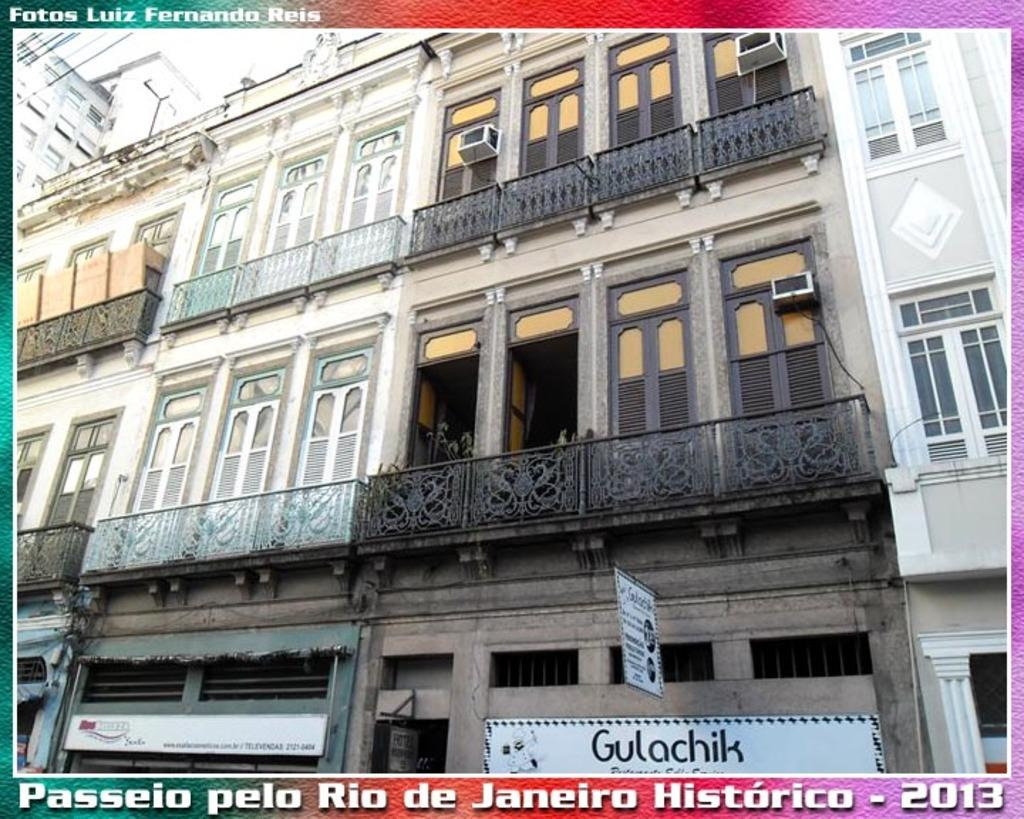What can be seen in the foreground of the image? In the foreground of the image, there are buildings, railings, and boards. Can you describe the buildings in the foreground? The buildings in the foreground are likely structures or establishments. What are the railings used for in the image? The railings in the foreground may be used for safety or to guide people. What are the boards in the foreground used for? The boards in the foreground may be used for signage or advertisements. Can you see a giraffe eating at a feast in the image? No, there is no giraffe or feast present in the image. How many drops of water can be seen falling from the boards in the image? There is no mention of water or drops in the image, so it is impossible to determine the number of drops. 